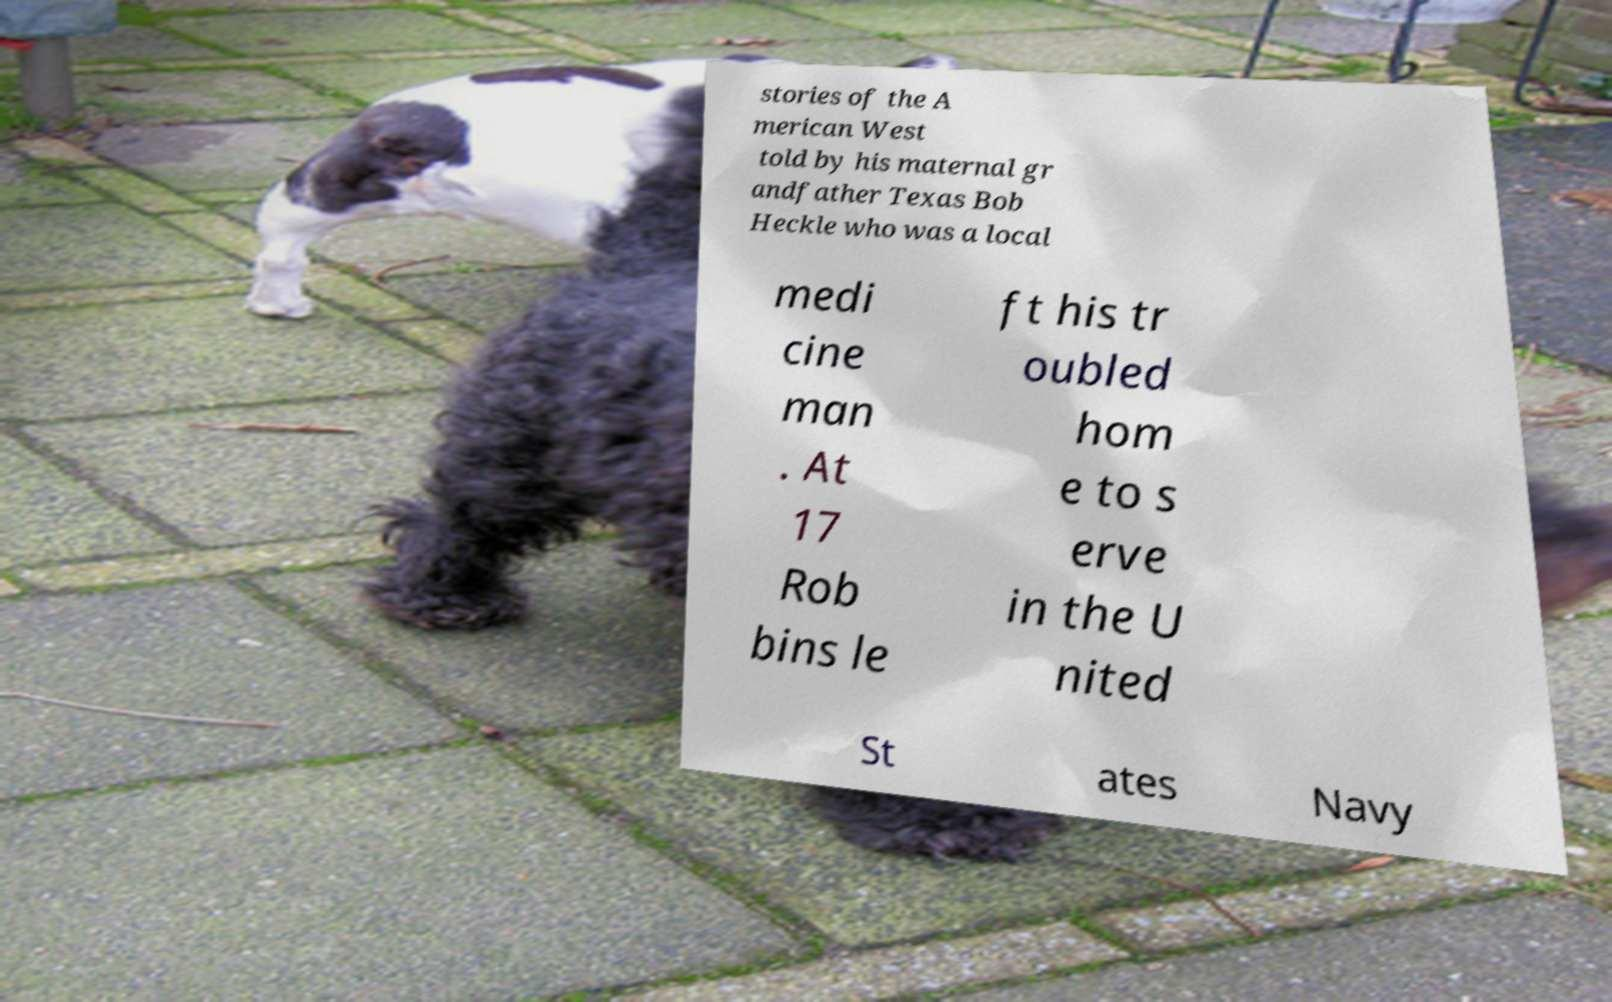I need the written content from this picture converted into text. Can you do that? stories of the A merican West told by his maternal gr andfather Texas Bob Heckle who was a local medi cine man . At 17 Rob bins le ft his tr oubled hom e to s erve in the U nited St ates Navy 